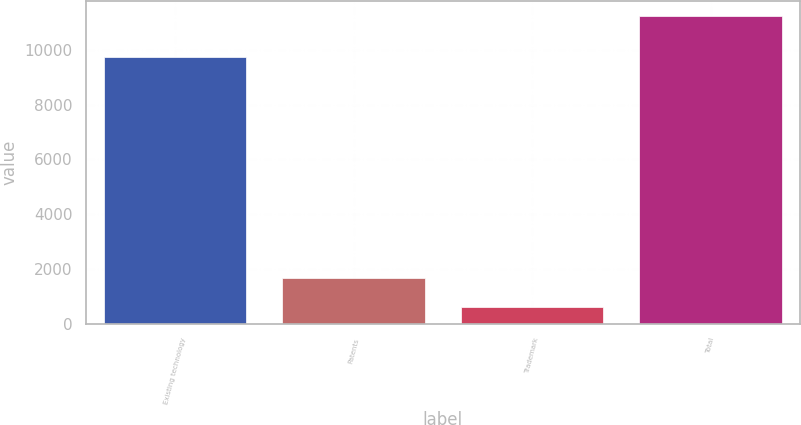Convert chart to OTSL. <chart><loc_0><loc_0><loc_500><loc_500><bar_chart><fcel>Existing technology<fcel>Patents<fcel>Trademark<fcel>Total<nl><fcel>9730<fcel>1683.2<fcel>623<fcel>11225<nl></chart> 